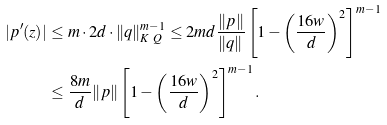<formula> <loc_0><loc_0><loc_500><loc_500>| p ^ { \prime } ( z ) | & \leq m \cdot 2 d \cdot \| q \| ^ { m - 1 } _ { K \ Q } \leq 2 m d \frac { \| p \| } { \| q \| } \left [ 1 - \left ( \frac { 1 6 w } { d } \right ) ^ { 2 } \right ] ^ { m - 1 } \\ & \leq \frac { 8 m } { d } \| p \| \left [ 1 - \left ( \frac { 1 6 w } { d } \right ) ^ { 2 } \right ] ^ { m - 1 } .</formula> 